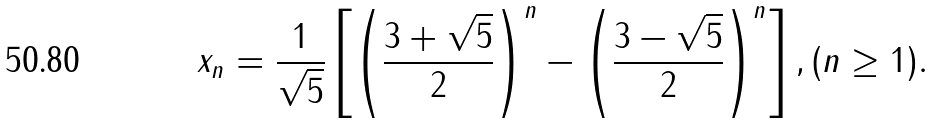Convert formula to latex. <formula><loc_0><loc_0><loc_500><loc_500>x _ { n } = \frac { 1 } { \sqrt { 5 } } \left [ \left ( \frac { 3 + \sqrt { 5 } } { 2 } \right ) ^ { n } - \left ( \frac { 3 - \sqrt { 5 } } { 2 } \right ) ^ { n } \right ] , ( n \geq 1 ) .</formula> 